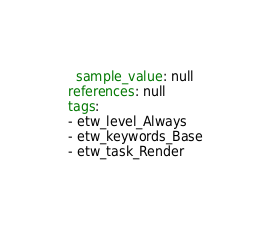<code> <loc_0><loc_0><loc_500><loc_500><_YAML_>  sample_value: null
references: null
tags:
- etw_level_Always
- etw_keywords_Base
- etw_task_Render
</code> 